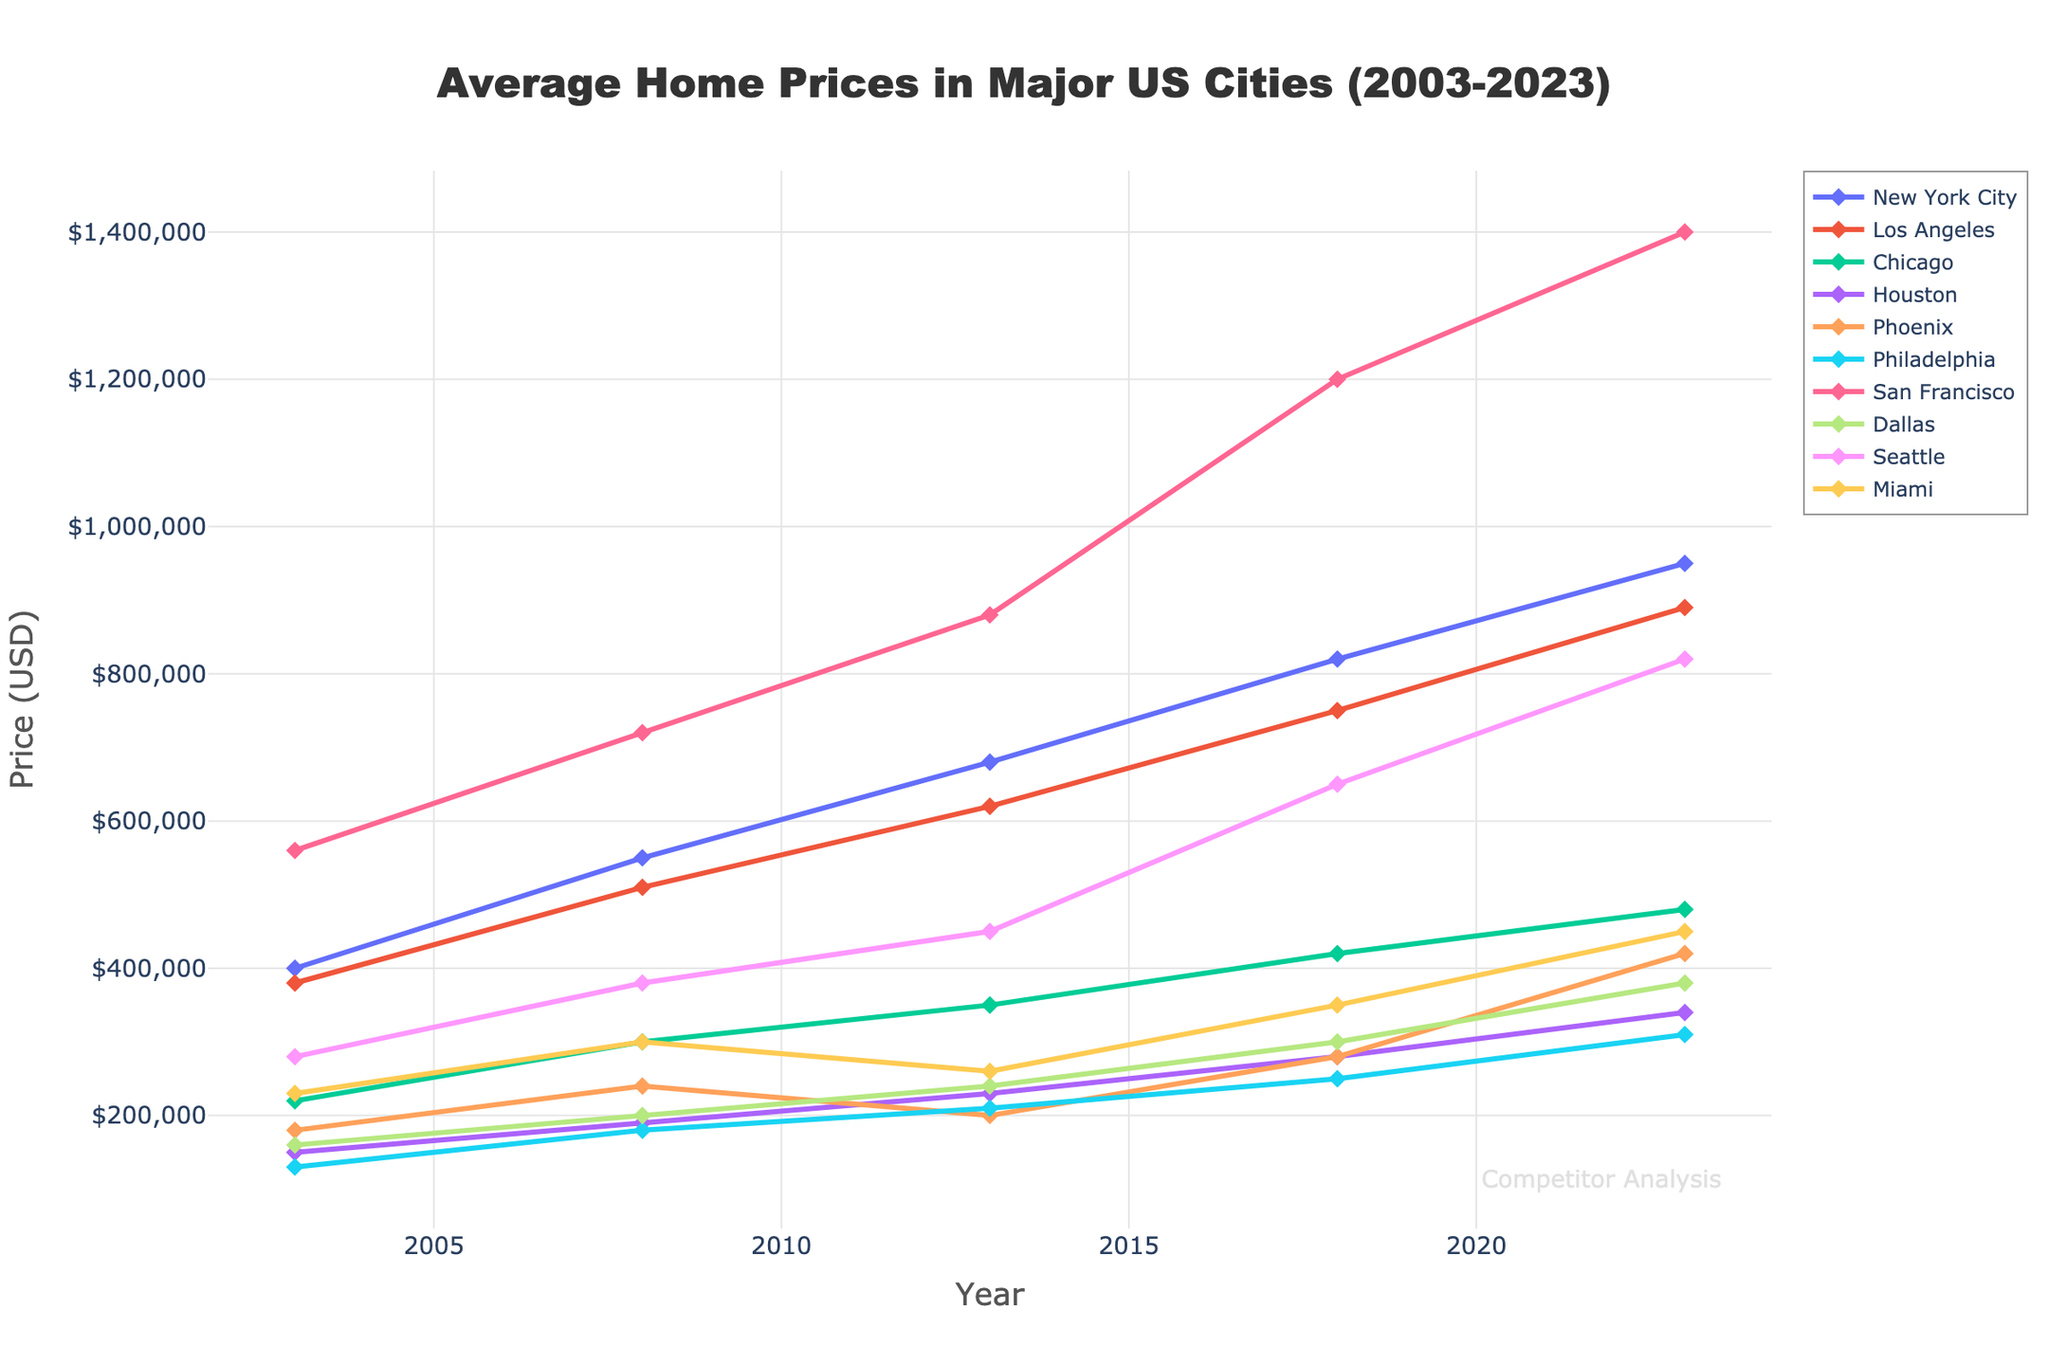What's the average home price in New York City for the years provided? First, sum up the home prices for New York City: 400,000 + 550,000 + 680,000 + 820,000 + 950,000 = 3,400,000. Then, divide by the number of years (5). The average is 3,400,000 / 5.
Answer: 680,000 Which city had the highest average home price in 2023? Look at the 2023 data points for each city and compare them: New York City (950,000), Los Angeles (890,000), Chicago (480,000), Houston (340,000), Phoenix (420,000), Philadelphia (310,000), San Francisco (1,400,000), Dallas (380,000), Seattle (820,000), Miami (450,000). San Francisco is the highest.
Answer: San Francisco By how much did home prices in Houston increase from 2003 to 2023? Subtract the 2003 price from the 2023 price for Houston: 340,000 - 150,000 = 190,000
Answer: 190,000 Which city showed the greatest increase in home prices between 2013 and 2023? Calculate the differences for each city: New York City (950,000-680,000 = 270,000), Los Angeles (890,000-620,000 = 270,000), Chicago (480,000-350,000 = 130,000), Houston (340,000-230,000 = 110,000), Phoenix (420,000-200,000 = 220,000), Philadelphia (310,000-210,000 = 100,000), San Francisco (1,400,000-880,000 = 520,000), Dallas (380,000-240,000 = 140,000), Seattle (820,000-450,000 = 370,000), Miami (450,000-260,000 = 190,000). San Francisco has the greatest increase.
Answer: San Francisco What is the trend in average home prices for Chicago from 2003 to 2023? Observe and describe the line path for Chicago: starting at a lower price point in 2003 (220,000), the prices steadily increase over the years, reaching 480,000 in 2023.
Answer: Steady increase Compare the home price trends of Seattle and Phoenix. Which city showed a more substantial rise between 2003 and 2023? Calculate the differences for each city: Seattle (820,000-280,000 = 540,000), Phoenix (420,000-180,000 = 240,000). Seattle shows a more substantial rise.
Answer: Seattle Which city had a noticeable decrease in home prices in any given period? Look for downward trends in any city's line: Phoenix shows a decrease between 2008 and 2013 (from 240,000 to 200,000).
Answer: Phoenix What was the price difference between the most and least expensive cities in 2023? Identify the highest and lowest prices in 2023: San Francisco (1,400,000), Philadelphia (310,000). Subtract the lowest from the highest: 1,400,000 - 310,000 = 1,090,000
Answer: 1,090,000 How does the price increase from 2003 to 2023 for Los Angeles compare to Miami? Calculate the differences: Los Angeles (890,000-380,000 = 510,000), Miami (450,000-230,000 = 220,000). Compare the two increases.
Answer: Los Angeles increase is higher What was the median home price in 2018 among all cities? List the 2018 prices: 820,000 (NYC), 750,000 (LA), 420,000 (Chicago), 280,000 (Houston), 280,000 (Phoenix), 250,000 (Philadelphia), 1,200,000 (San Francisco), 300,000 (Dallas), 650,000 (Seattle), 350,000 (Miami). Arrange them in ascending order: 250,000, 280,000, 280,000, 300,000, 350,000, 420,000, 650,000, 750,000, 820,000, 1,200,000. The middle value is 350,000.
Answer: 350,000 